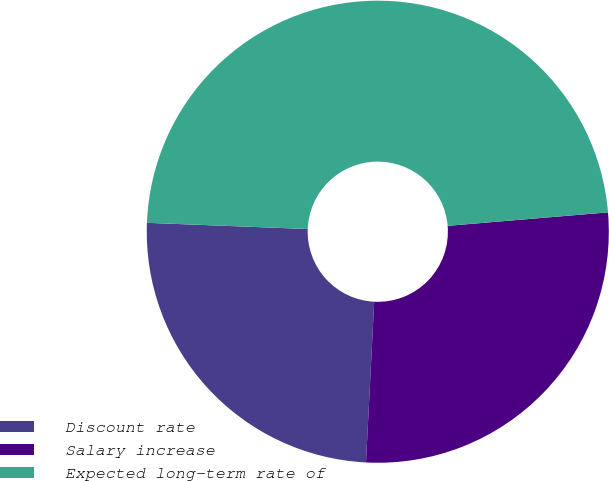Convert chart. <chart><loc_0><loc_0><loc_500><loc_500><pie_chart><fcel>Discount rate<fcel>Salary increase<fcel>Expected long-term rate of<nl><fcel>24.8%<fcel>27.15%<fcel>48.05%<nl></chart> 